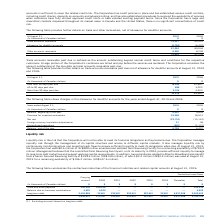According to Cogeco's financial document, What is the definition of trade accounts receivable past due? Trade accounts receivable past due is defined as the amount outstanding beyond normal credit terms and conditions for the respective customers.. The document states: "Trade accounts receivable past due is defined as the amount outstanding beyond normal credit terms and conditions for the respective customers. A larg..." Also, What is the trade accounts receivable in 2019 less than 60 days past due? According to the financial document, 18,645 (in thousands). The relevant text states: "Less than 60 days past due 18,645 32,857..." Also, What is the trade accounts receivable in 2018 less than 60 days past due? According to the financial document, 32,857 (in thousands). The relevant text states: "Less than 60 days past due 18,645 32,857..." Also, can you calculate: What was the increase / (decrease) in trade accounts receivable less than 60 days past due? Based on the calculation: 18,645 - 32,857, the result is -14212 (in thousands). This is based on the information: "Less than 60 days past due 18,645 32,857 Less than 60 days past due 18,645 32,857..." The key data points involved are: 18,645, 32,857. Also, can you calculate: What was the average trade accounts receivable 60 to 90 days past due? To answer this question, I need to perform calculations using the financial data. The calculation is: (899 + 3,022) / 2, which equals 1960.5 (in thousands). This is based on the information: "60 to 90 days past due 899 3,022 60 to 90 days past due 899 3,022..." The key data points involved are: 3,022, 899. Also, can you calculate: What was the average trade accounts receivable more than 90 days past due? To answer this question, I need to perform calculations using the financial data. The calculation is: (3,074 + 4,923) / 2, which equals 3998.5 (in thousands). This is based on the information: "More than 90 days past due 3,074 4,923 More than 90 days past due 3,074 4,923..." The key data points involved are: 3,074, 4,923. 